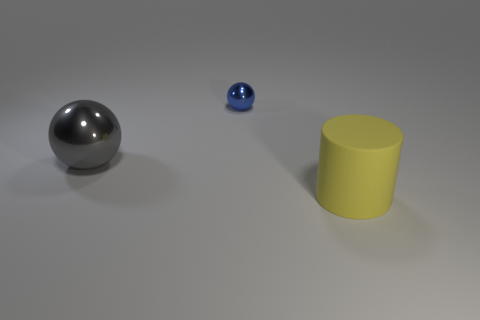Is there any other thing that has the same material as the large yellow cylinder?
Provide a short and direct response. No. What material is the large object left of the large thing to the right of the large object behind the large yellow object?
Keep it short and to the point. Metal. Does the large thing that is on the left side of the yellow matte cylinder have the same color as the big rubber thing?
Keep it short and to the point. No. How many yellow things are balls or large objects?
Provide a short and direct response. 1. How many other objects are there of the same shape as the large gray metal thing?
Offer a very short reply. 1. Does the big cylinder have the same material as the blue ball?
Make the answer very short. No. What material is the object that is in front of the small blue metal ball and on the left side of the big rubber cylinder?
Give a very brief answer. Metal. What color is the metallic thing that is in front of the blue ball?
Offer a very short reply. Gray. Are there more objects to the right of the blue metallic sphere than big shiny spheres?
Give a very brief answer. No. How many other things are the same size as the blue shiny thing?
Provide a short and direct response. 0. 